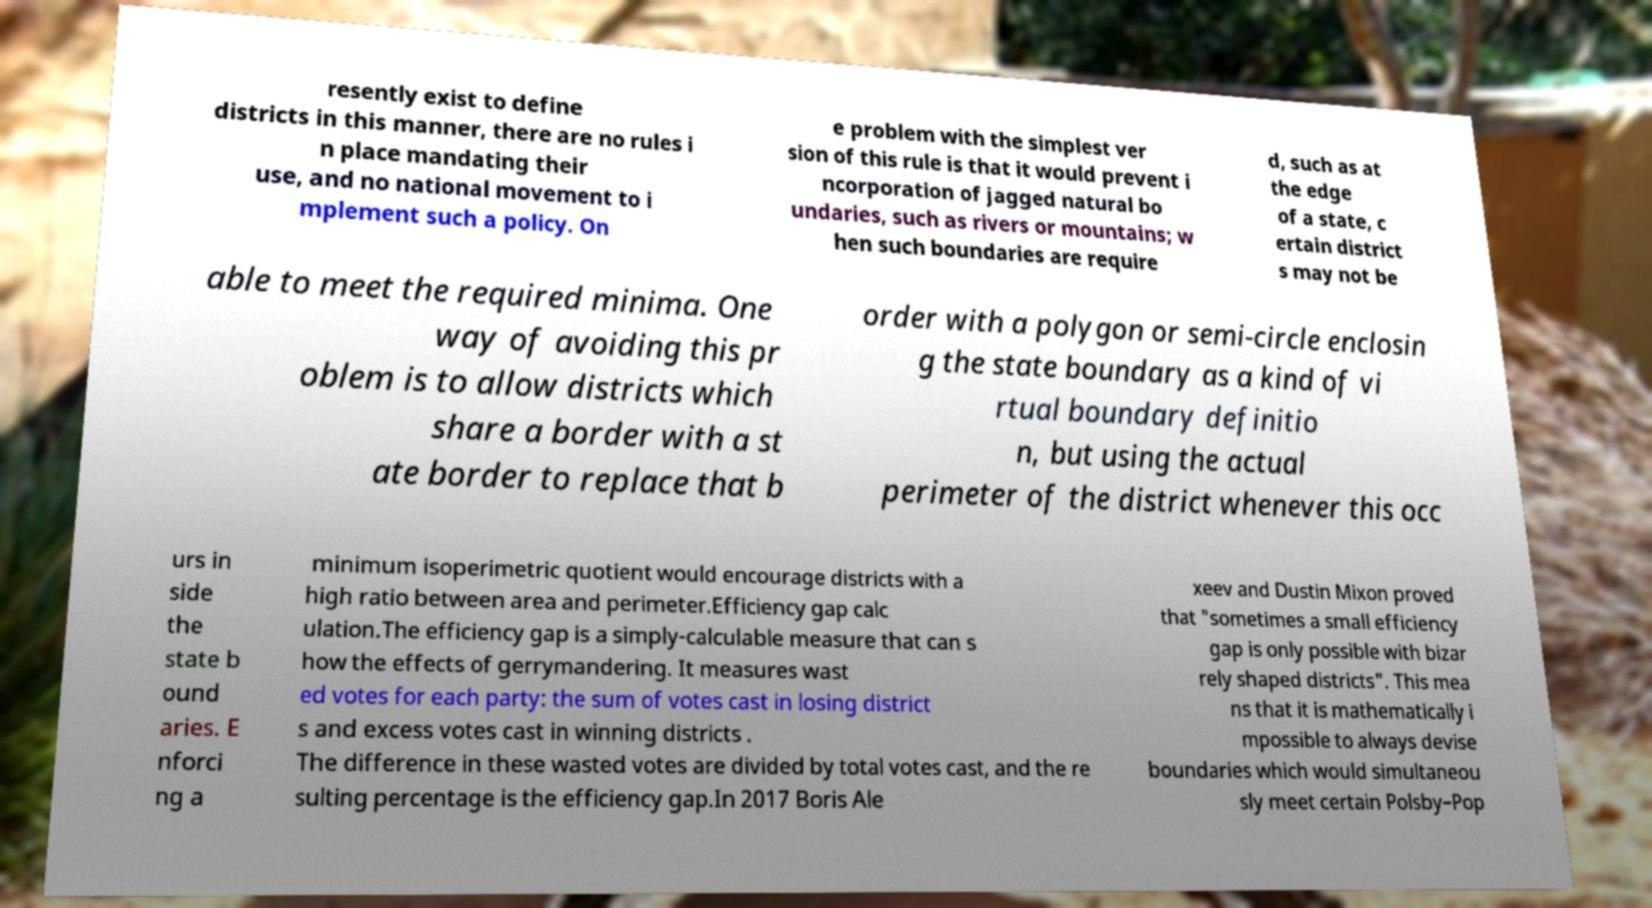Could you extract and type out the text from this image? resently exist to define districts in this manner, there are no rules i n place mandating their use, and no national movement to i mplement such a policy. On e problem with the simplest ver sion of this rule is that it would prevent i ncorporation of jagged natural bo undaries, such as rivers or mountains; w hen such boundaries are require d, such as at the edge of a state, c ertain district s may not be able to meet the required minima. One way of avoiding this pr oblem is to allow districts which share a border with a st ate border to replace that b order with a polygon or semi-circle enclosin g the state boundary as a kind of vi rtual boundary definitio n, but using the actual perimeter of the district whenever this occ urs in side the state b ound aries. E nforci ng a minimum isoperimetric quotient would encourage districts with a high ratio between area and perimeter.Efficiency gap calc ulation.The efficiency gap is a simply-calculable measure that can s how the effects of gerrymandering. It measures wast ed votes for each party: the sum of votes cast in losing district s and excess votes cast in winning districts . The difference in these wasted votes are divided by total votes cast, and the re sulting percentage is the efficiency gap.In 2017 Boris Ale xeev and Dustin Mixon proved that "sometimes a small efficiency gap is only possible with bizar rely shaped districts". This mea ns that it is mathematically i mpossible to always devise boundaries which would simultaneou sly meet certain Polsby–Pop 